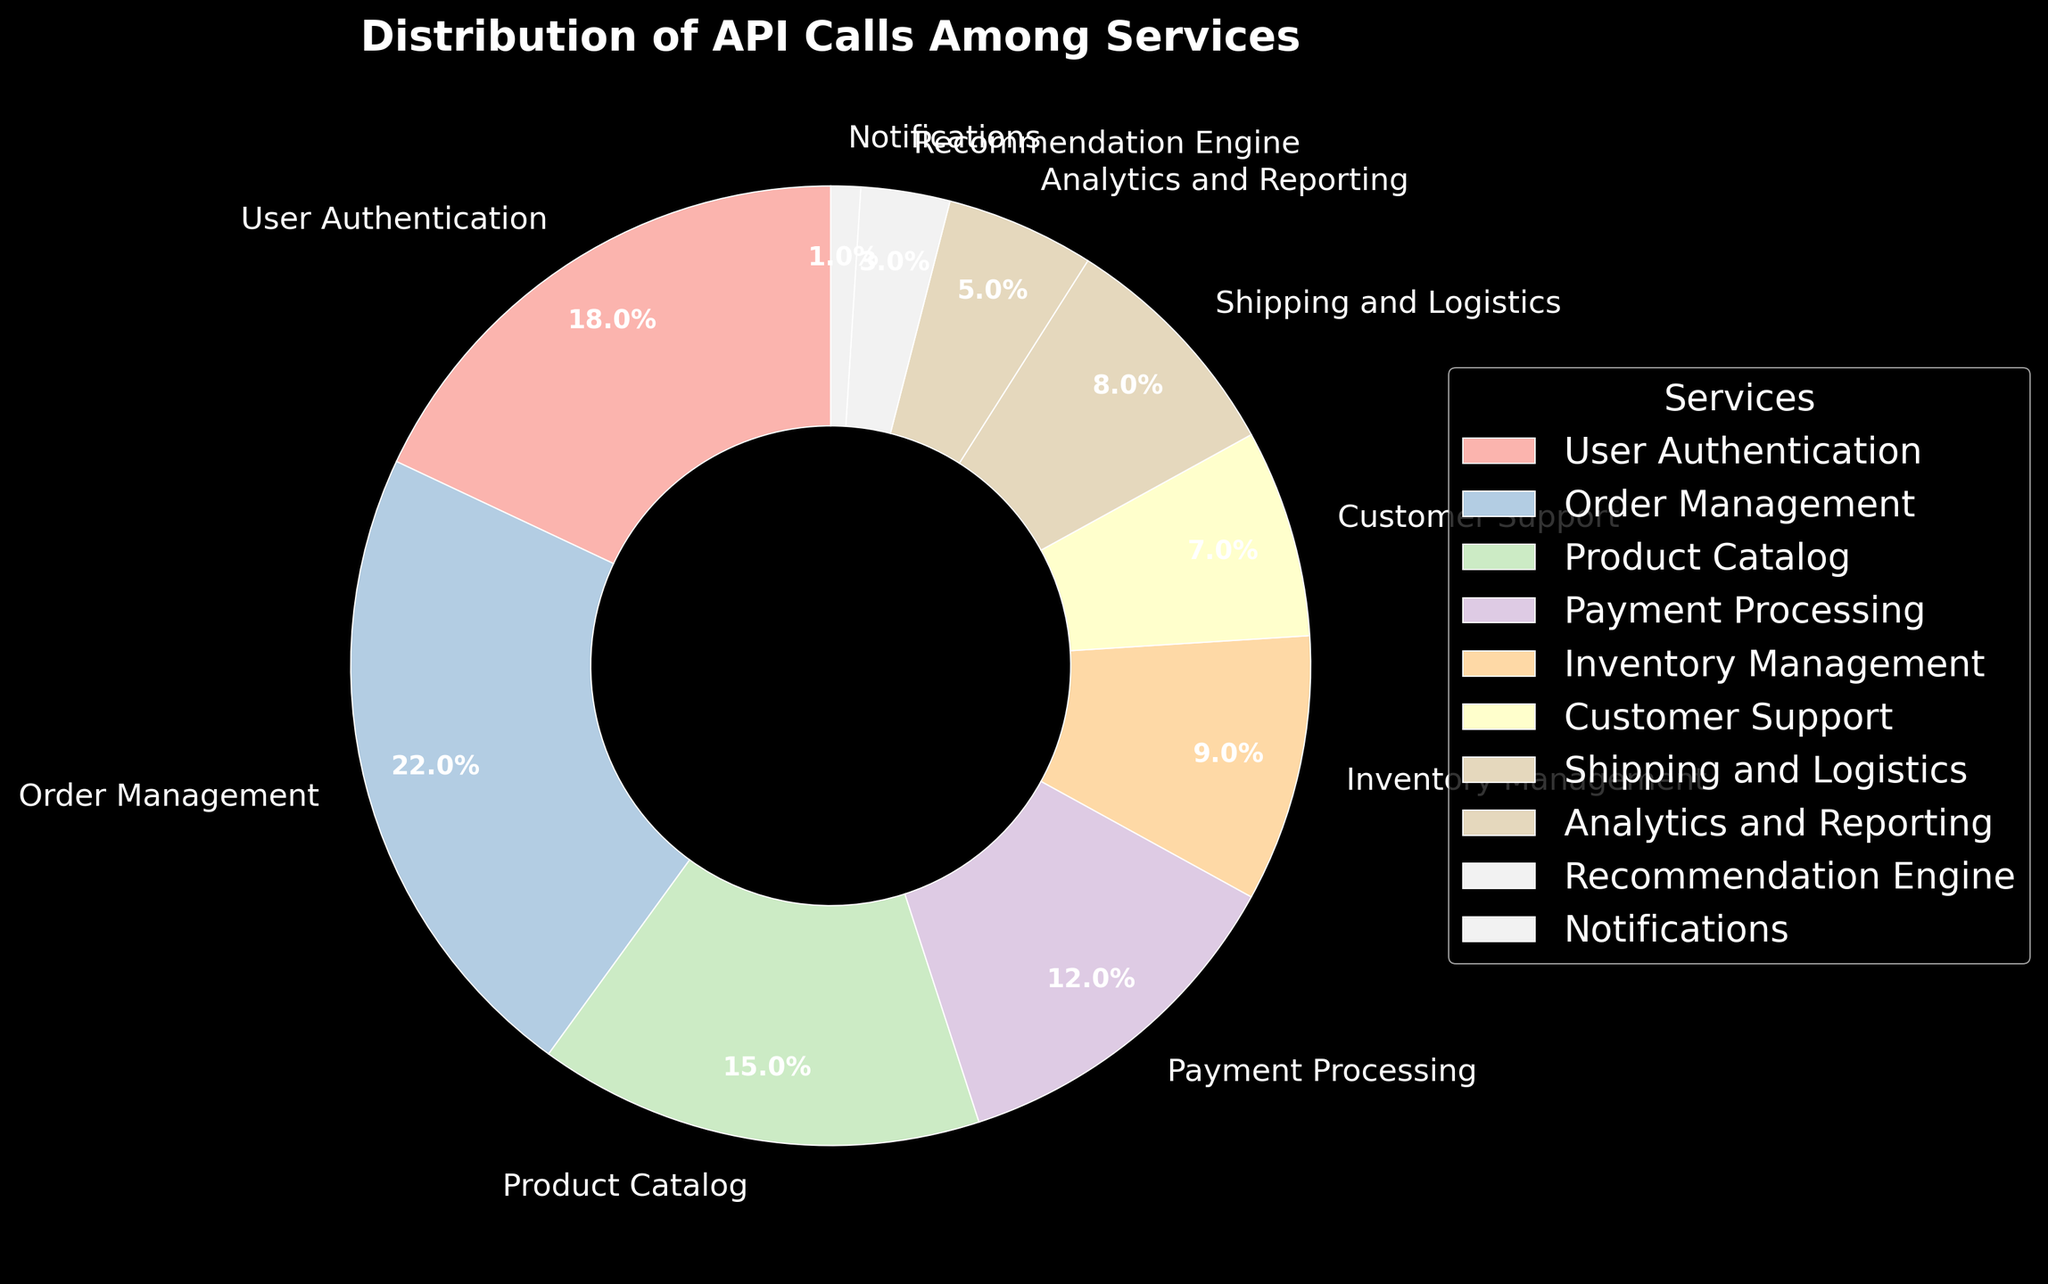Which service has the highest percentage of API calls? By looking at the pie chart, the Order Management service takes up the largest slice of the pie, indicating it has the highest percentage of API calls.
Answer: Order Management What is the combined percentage of API calls for User Authentication and Payment Processing services? The percentages for User Authentication and Payment Processing services are 18% and 12%, respectively. Adding these together gives 18% + 12% = 30%.
Answer: 30% How does the percentage of API calls for Inventory Management compare to Analytics and Reporting? The percentage for Inventory Management is 9%, while for Analytics and Reporting, it is 5%. When comparing, 9% is greater than 5%.
Answer: Inventory Management is greater What is the difference between the percentage of API calls for Order Management and Customer Support? The percentage for Order Management is 22% and for Customer Support, it is 7%. The difference is 22% - 7% = 15%.
Answer: 15% Are there more API calls for Shipping and Logistics or Product Catalog? The percentage for Shipping and Logistics is 8%, while for Product Catalog, it is 15%. More calls are made for Product Catalog than Shipping and Logistics.
Answer: Product Catalog What is the total percentage of API calls accounted for by the three services with the lowest percentages? The three services with the lowest percentages are Notifications (1%), Recommendation Engine (3%), and Analytics and Reporting (5%). Summing these gives 1% + 3% + 5% = 9%.
Answer: 9% Which service has the second highest percentage of API calls, and what is that percentage? The highest percentage belongs to Order Management at 22%. The second highest is User Authentication with 18%.
Answer: User Authentication with 18% What is the proportion of API calls for Customer Support compared to Shipping and Logistics? The percentage for Customer Support is 7%, and for Shipping and Logistics, it is 8%. The ratio of Customer Support to Shipping and Logistics is 7/8 or 0.875.
Answer: 0.875 How much more in percentage points does Order Management receive in API calls than Payment Processing? Order Management receives 22% of the API calls, whereas Payment Processing receives 12%. The difference is 22% - 12% = 10 percentage points.
Answer: 10 percentage points What percentage of API calls do the top three services combined contribute? The top three services are Order Management (22%), User Authentication (18%), and Product Catalog (15%). Adding these together, 22% + 18% + 15% = 55%.
Answer: 55% 